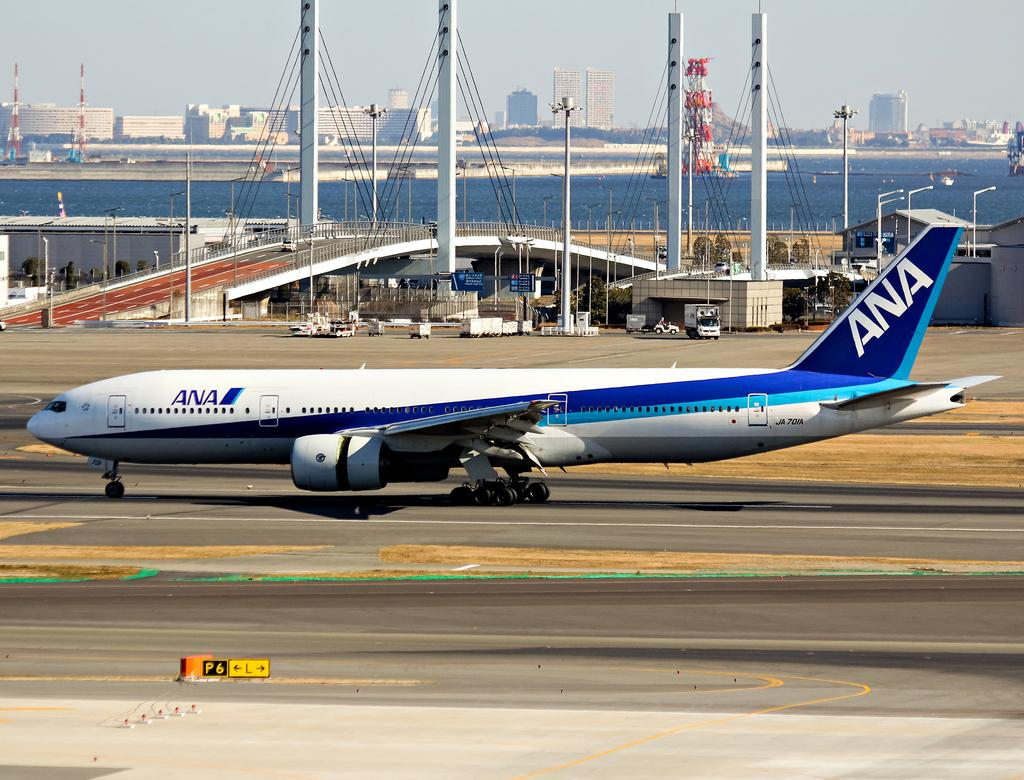Provide a one-sentence caption for the provided image. An ANA airplane that is sitting on a runway. 